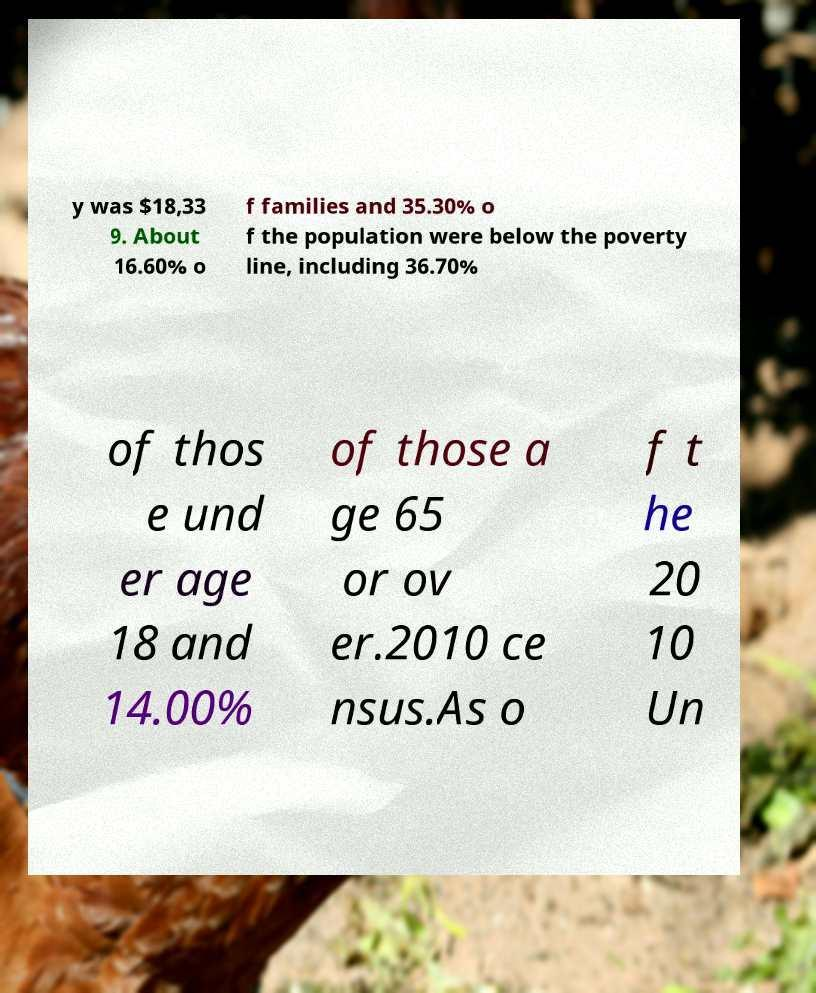Please identify and transcribe the text found in this image. y was $18,33 9. About 16.60% o f families and 35.30% o f the population were below the poverty line, including 36.70% of thos e und er age 18 and 14.00% of those a ge 65 or ov er.2010 ce nsus.As o f t he 20 10 Un 